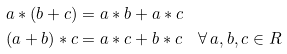Convert formula to latex. <formula><loc_0><loc_0><loc_500><loc_500>a * ( b + c ) & = a * b + a * c \\ ( a + b ) * c & = a * c + b * c \quad \forall \, a , b , c \in R</formula> 